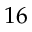Convert formula to latex. <formula><loc_0><loc_0><loc_500><loc_500>1 6</formula> 